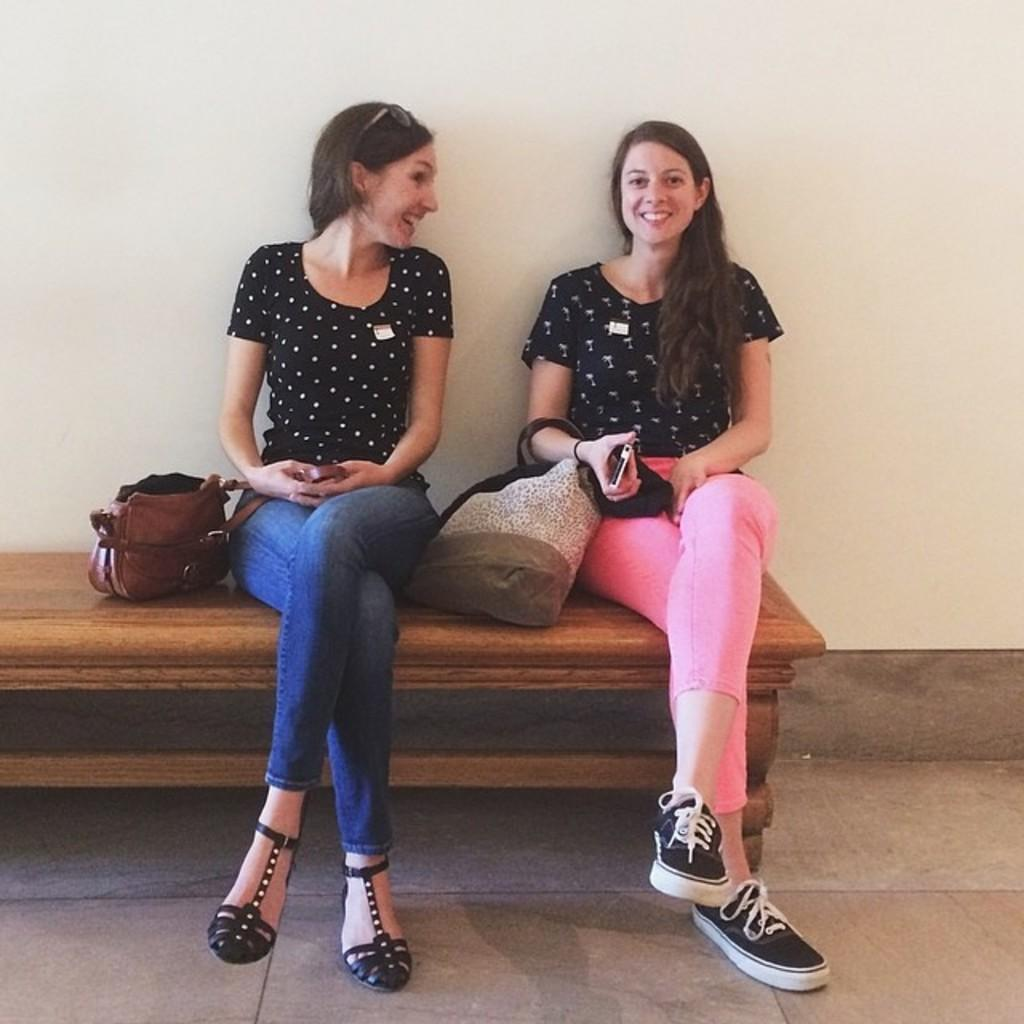How many people are in the image? There are two ladies in the image. What are the ladies doing in the image? The ladies are sitting on a bench. What are the ladies wearing in the image? Both ladies are wearing black t-shirts. What else can be seen on the bench in the image? There are bags on the bench. What type of kettle can be seen in the image? There is no kettle present in the image. What kind of flower is growing near the bench in the image? There is no flower present in the image. 